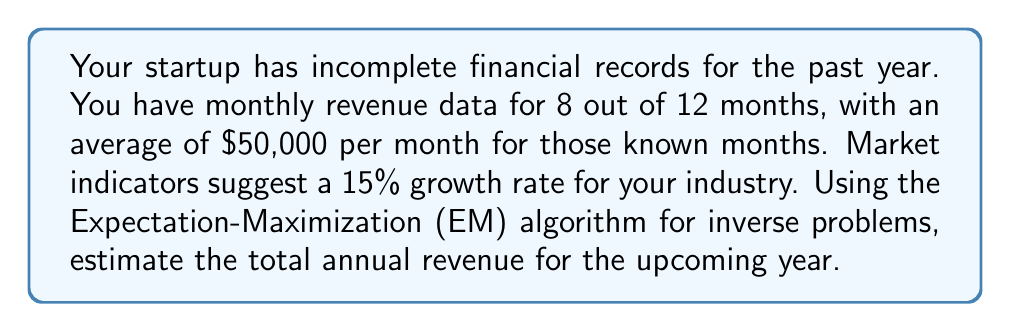Could you help me with this problem? Let's approach this step-by-step using the EM algorithm:

1) Initialize:
   Let's assume the missing months have the same average as the known months.
   Initial estimate: $50,000 * 12 = $600,000 for the past year

2) Expectation step:
   Given the 15% growth rate, expect next year's revenue to be:
   $600,000 * 1.15 = $690,000

3) Maximization step:
   Refine our estimate using the known data:
   Known months: 8 * $50,000 = $400,000
   Unknown months: 4 * x
   Total: $400,000 + 4x = $690,000 / 1.15 = $600,000
   Solve for x:
   $400,000 + 4x = $600,000
   4x = $200,000
   x = $50,000

4) Iterate:
   Our refined estimate matches the initial guess, so no further iterations are needed.

5) Final calculation:
   Estimated revenue for next year:
   $600,000 * 1.15 = $690,000

The EM algorithm has helped us estimate the missing data and project future revenue based on incomplete information and market trends, a common challenge in startup financial planning.
Answer: $690,000 